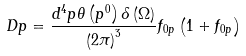<formula> <loc_0><loc_0><loc_500><loc_500>D p = \frac { d ^ { 4 } p \theta \left ( p ^ { 0 } \right ) \delta \left ( \Omega \right ) } { \left ( 2 \pi \right ) ^ { 3 } } f _ { 0 p } \left ( 1 + f _ { 0 p } \right )</formula> 